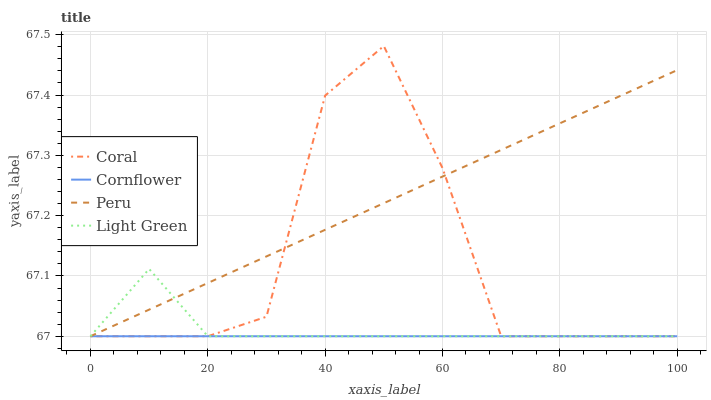Does Cornflower have the minimum area under the curve?
Answer yes or no. Yes. Does Peru have the maximum area under the curve?
Answer yes or no. Yes. Does Coral have the minimum area under the curve?
Answer yes or no. No. Does Coral have the maximum area under the curve?
Answer yes or no. No. Is Cornflower the smoothest?
Answer yes or no. Yes. Is Coral the roughest?
Answer yes or no. Yes. Is Light Green the smoothest?
Answer yes or no. No. Is Light Green the roughest?
Answer yes or no. No. Does Cornflower have the lowest value?
Answer yes or no. Yes. Does Coral have the highest value?
Answer yes or no. Yes. Does Light Green have the highest value?
Answer yes or no. No. Does Cornflower intersect Light Green?
Answer yes or no. Yes. Is Cornflower less than Light Green?
Answer yes or no. No. Is Cornflower greater than Light Green?
Answer yes or no. No. 